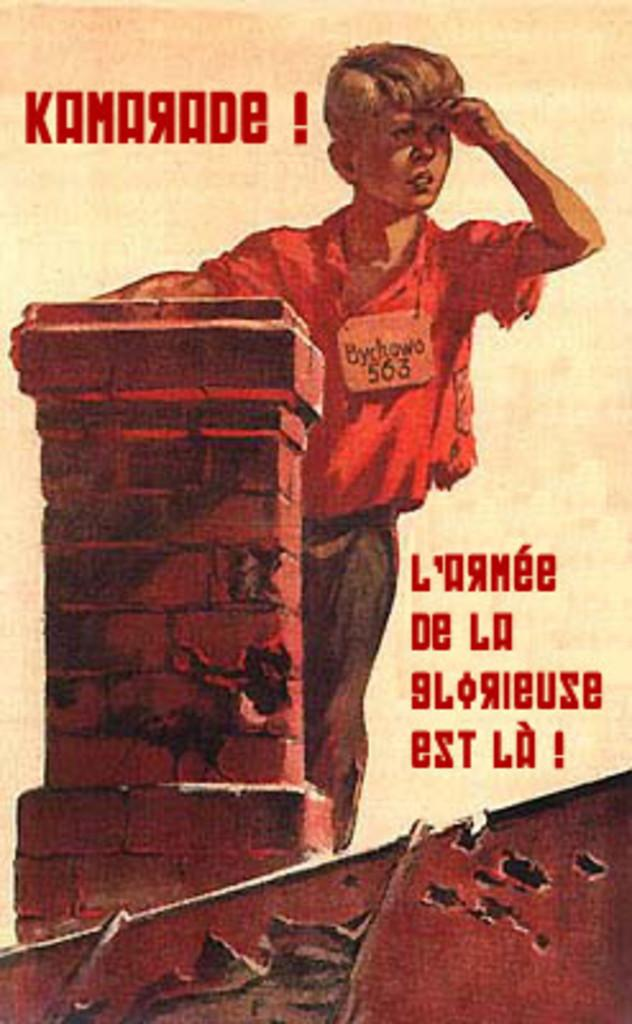What is the main subject of the image? There is a painting in the image. What type of pets are depicted in the painting? There is no information about pets in the image, as it only mentions the presence of a painting. 